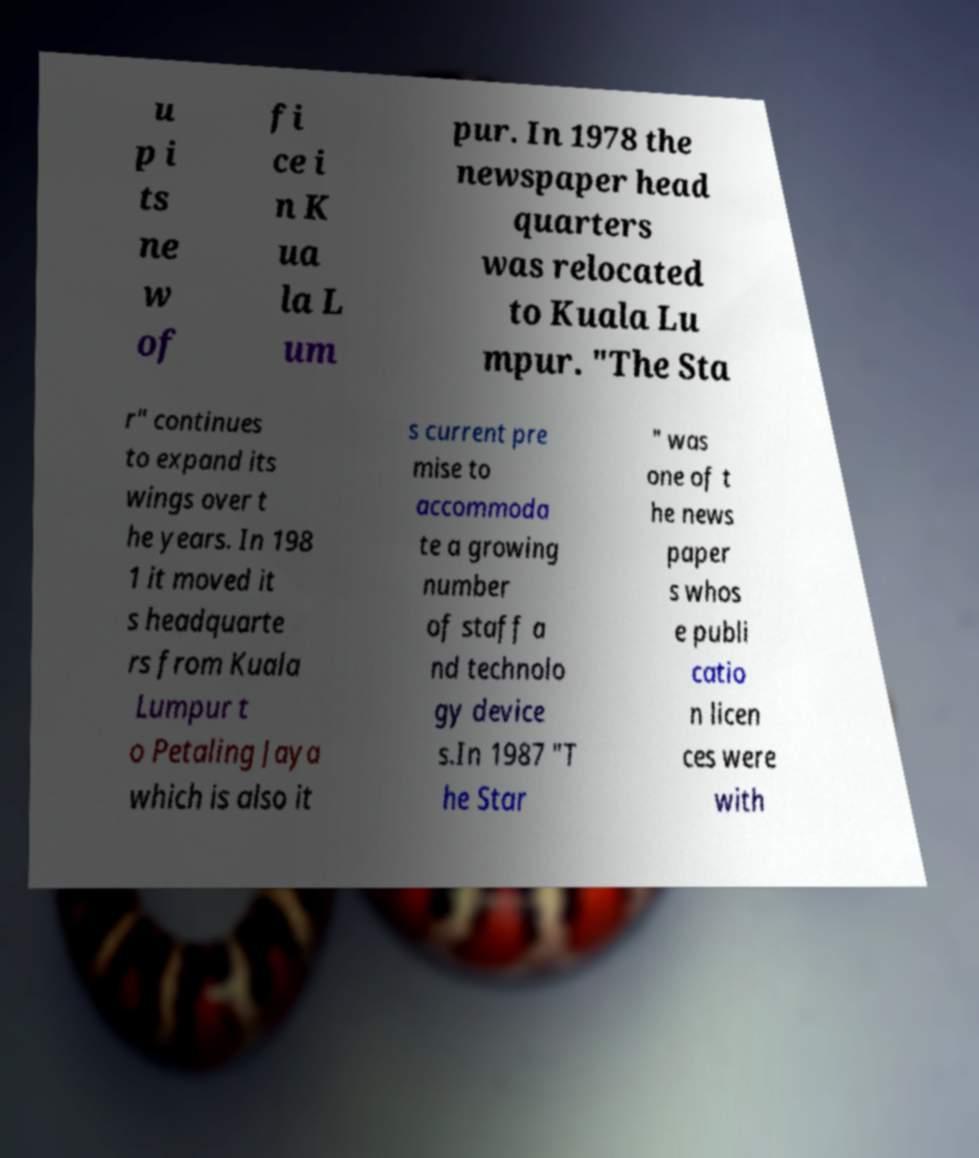Please identify and transcribe the text found in this image. u p i ts ne w of fi ce i n K ua la L um pur. In 1978 the newspaper head quarters was relocated to Kuala Lu mpur. "The Sta r" continues to expand its wings over t he years. In 198 1 it moved it s headquarte rs from Kuala Lumpur t o Petaling Jaya which is also it s current pre mise to accommoda te a growing number of staff a nd technolo gy device s.In 1987 "T he Star " was one of t he news paper s whos e publi catio n licen ces were with 